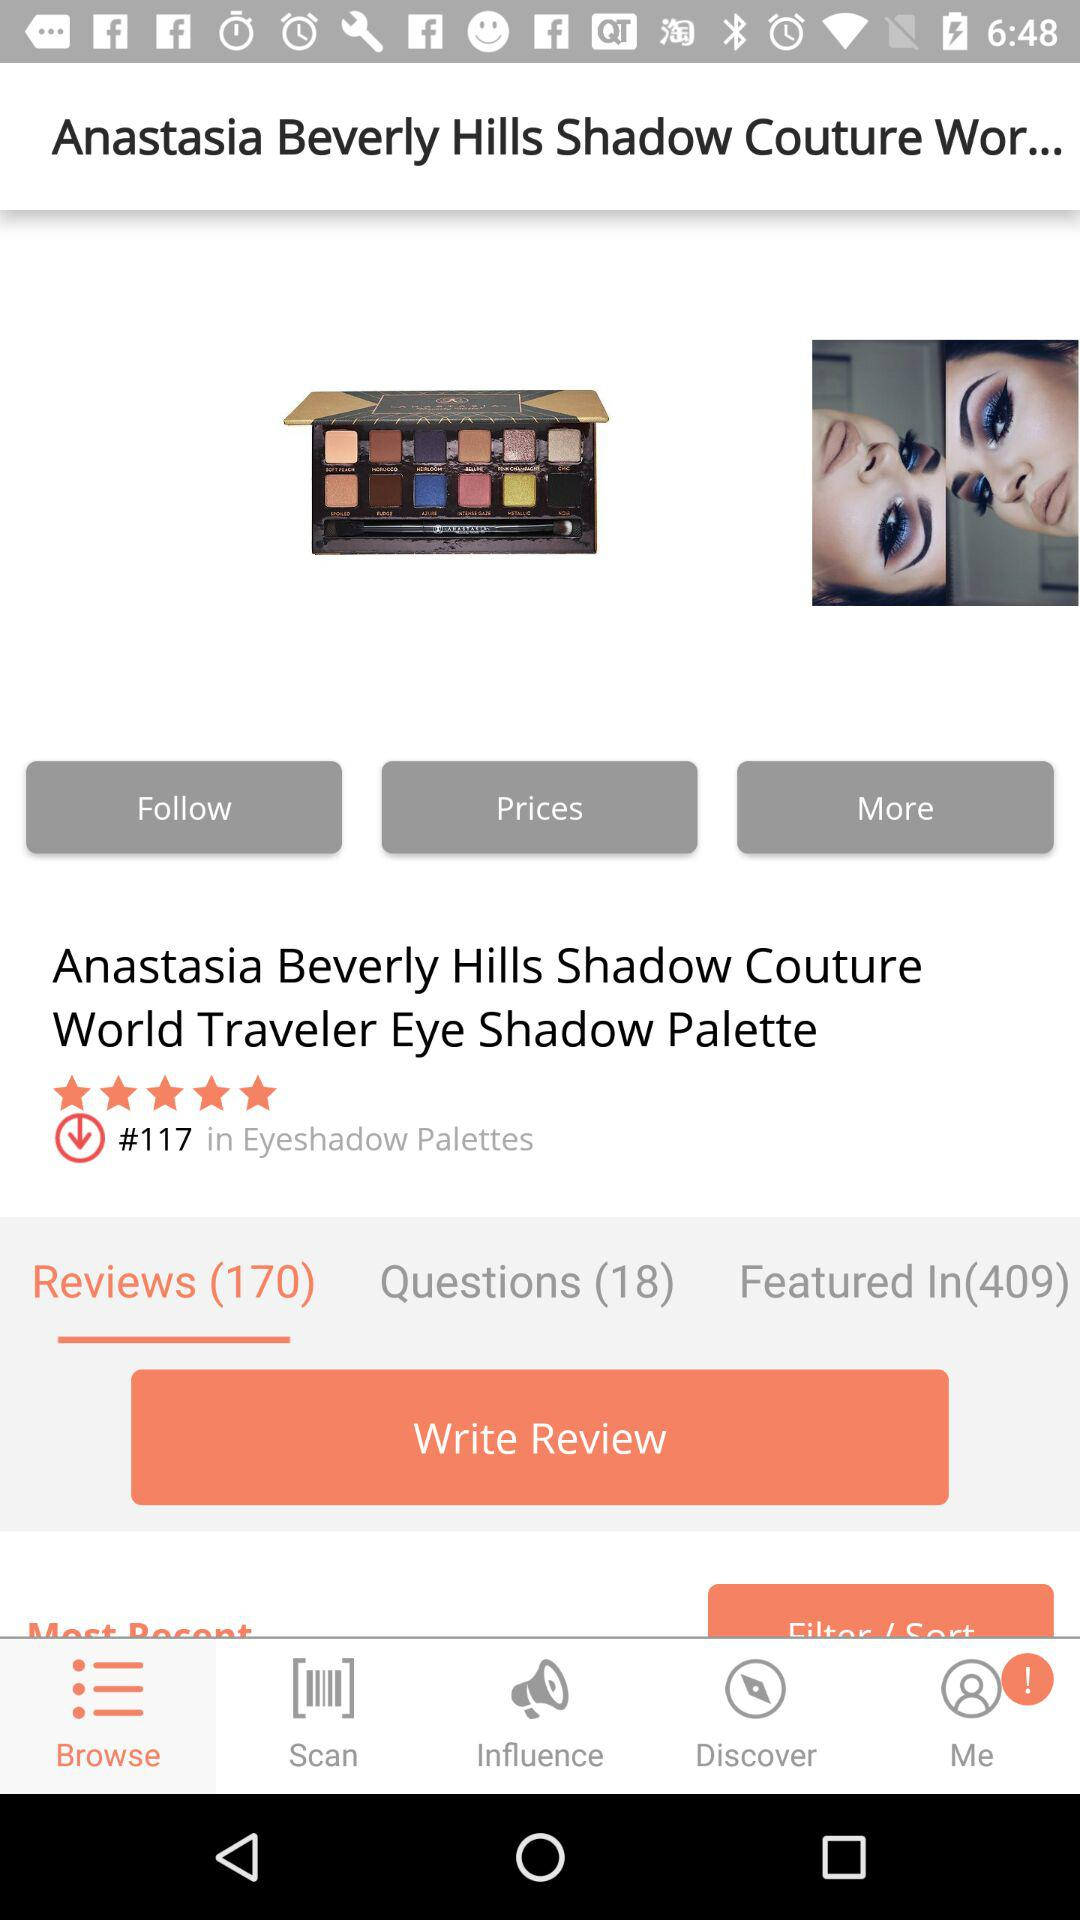How many reviews does the product have?
Answer the question using a single word or phrase. 170 